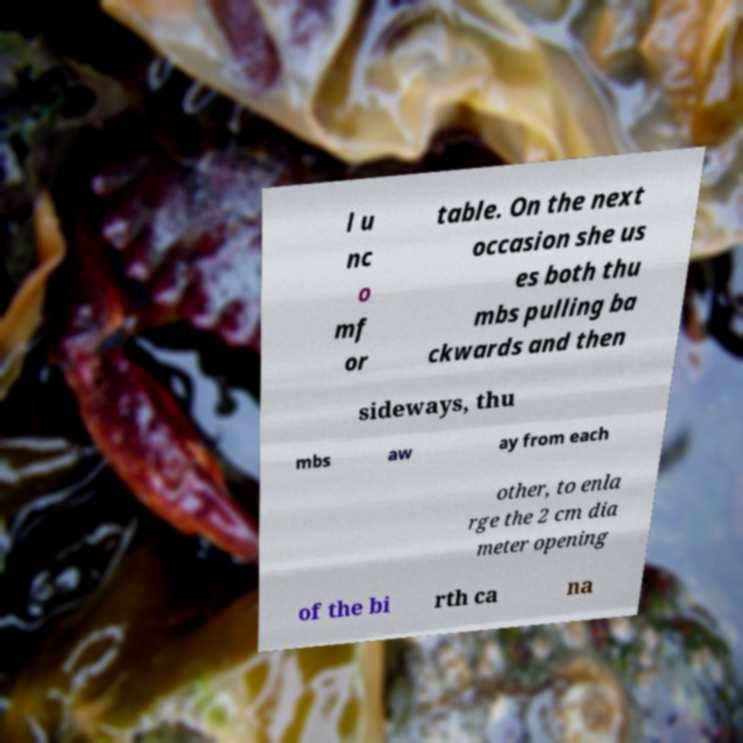There's text embedded in this image that I need extracted. Can you transcribe it verbatim? l u nc o mf or table. On the next occasion she us es both thu mbs pulling ba ckwards and then sideways, thu mbs aw ay from each other, to enla rge the 2 cm dia meter opening of the bi rth ca na 